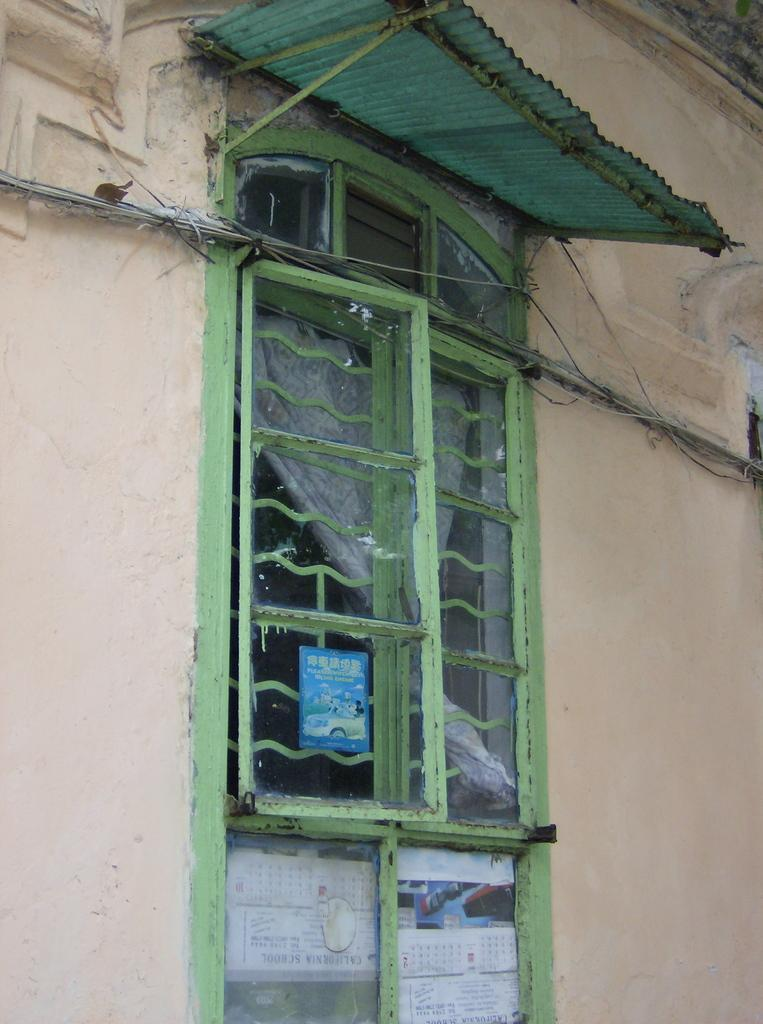What is a prominent feature of the wall in the image? There is a window in the wall. What is located near the wall in the image? There is a shed in the image. What is attached to the wall in the image? Wires are attached to the wall. What is placed on the window in the image? There are posters on the window. Can you see any mice wearing a crown in the image? There are no mice or crowns present in the image. What type of cake is being served in the image? There is no cake present in the image. 